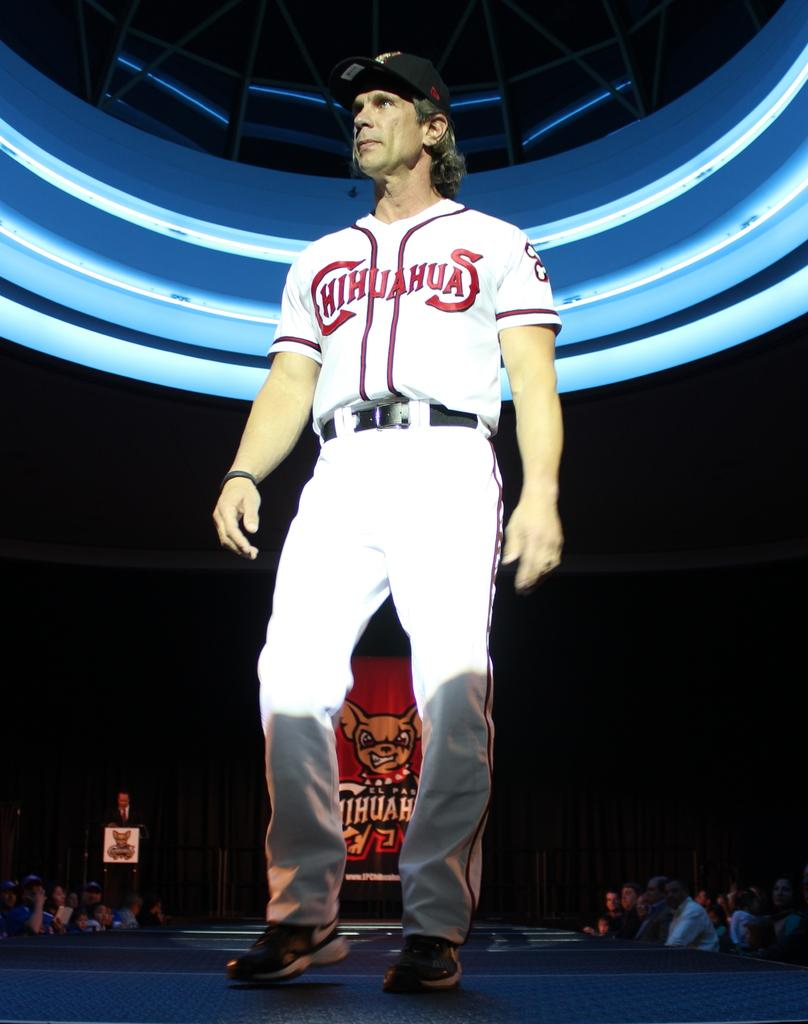<image>
Render a clear and concise summary of the photo. A baseball player is wearing jersey with Chihuahuas on front. 